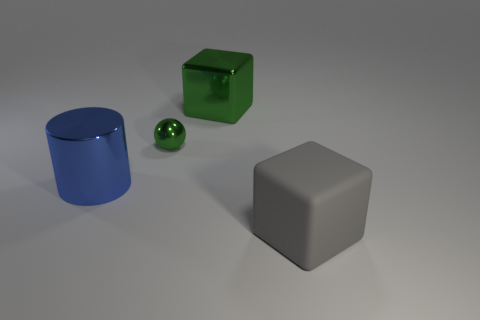What can you tell me about the lighting in this scene? The scene is lit from above, casting soft shadows beneath the objects. The lighting appears to be uniform, suggesting an indoor setting with a single, diffused light source, creating a calm and simplistic ambiance. 